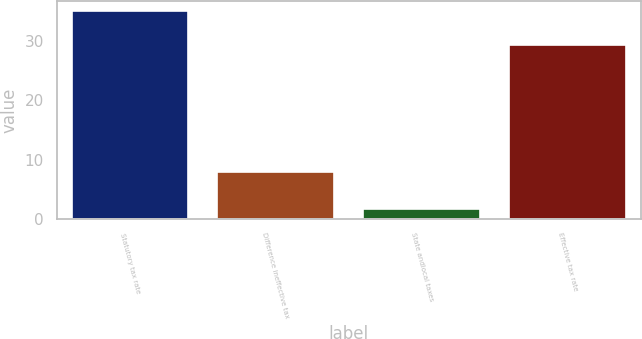Convert chart to OTSL. <chart><loc_0><loc_0><loc_500><loc_500><bar_chart><fcel>Statutory tax rate<fcel>Difference ineffective tax<fcel>State andlocal taxes<fcel>Effective tax rate<nl><fcel>35<fcel>8<fcel>1.7<fcel>29.3<nl></chart> 